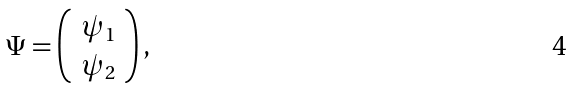<formula> <loc_0><loc_0><loc_500><loc_500>\Psi = \left ( \begin{array} { c } \psi _ { 1 } \\ \psi _ { 2 } \end{array} \right ) ,</formula> 